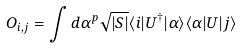Convert formula to latex. <formula><loc_0><loc_0><loc_500><loc_500>O _ { i , j } = \int d \alpha ^ { p } \sqrt { | S | } \langle i | U ^ { \dag } | \alpha \rangle \langle \alpha | U | j \rangle</formula> 